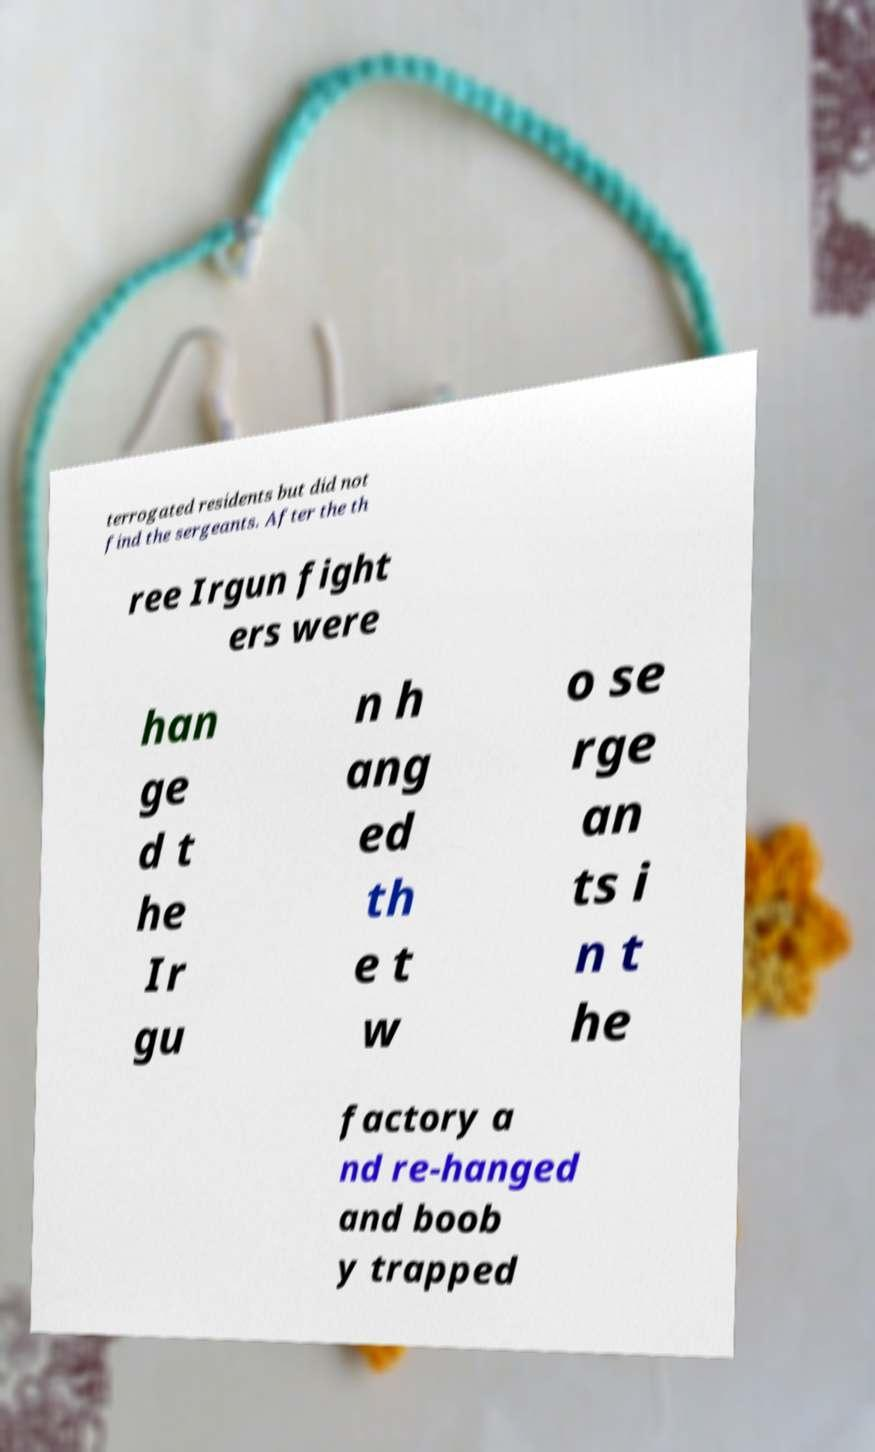I need the written content from this picture converted into text. Can you do that? terrogated residents but did not find the sergeants. After the th ree Irgun fight ers were han ge d t he Ir gu n h ang ed th e t w o se rge an ts i n t he factory a nd re-hanged and boob y trapped 